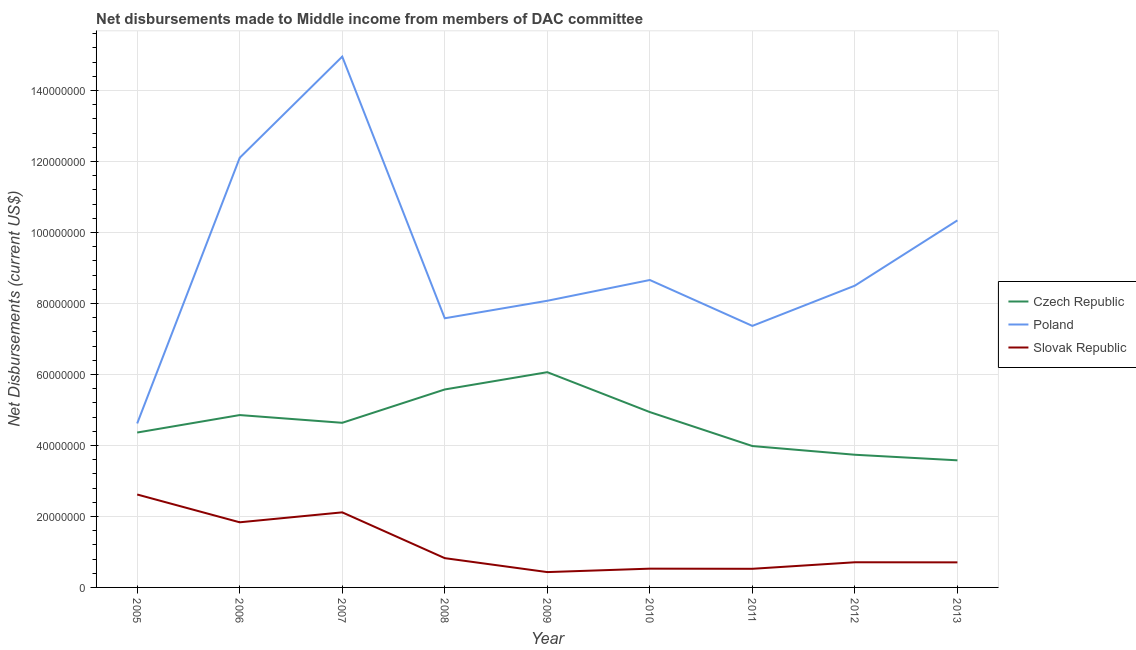Is the number of lines equal to the number of legend labels?
Give a very brief answer. Yes. What is the net disbursements made by czech republic in 2011?
Provide a succinct answer. 3.98e+07. Across all years, what is the maximum net disbursements made by slovak republic?
Your response must be concise. 2.62e+07. Across all years, what is the minimum net disbursements made by slovak republic?
Provide a short and direct response. 4.32e+06. In which year was the net disbursements made by czech republic minimum?
Offer a terse response. 2013. What is the total net disbursements made by slovak republic in the graph?
Offer a terse response. 1.03e+08. What is the difference between the net disbursements made by poland in 2010 and that in 2011?
Offer a very short reply. 1.29e+07. What is the difference between the net disbursements made by poland in 2007 and the net disbursements made by slovak republic in 2011?
Make the answer very short. 1.44e+08. What is the average net disbursements made by poland per year?
Offer a very short reply. 9.13e+07. In the year 2007, what is the difference between the net disbursements made by slovak republic and net disbursements made by czech republic?
Offer a terse response. -2.52e+07. What is the ratio of the net disbursements made by czech republic in 2007 to that in 2010?
Make the answer very short. 0.94. What is the difference between the highest and the second highest net disbursements made by poland?
Offer a terse response. 2.85e+07. What is the difference between the highest and the lowest net disbursements made by poland?
Your answer should be compact. 1.03e+08. Is the net disbursements made by slovak republic strictly greater than the net disbursements made by czech republic over the years?
Give a very brief answer. No. How many lines are there?
Your answer should be very brief. 3. What is the difference between two consecutive major ticks on the Y-axis?
Your answer should be very brief. 2.00e+07. Where does the legend appear in the graph?
Ensure brevity in your answer.  Center right. How many legend labels are there?
Make the answer very short. 3. How are the legend labels stacked?
Give a very brief answer. Vertical. What is the title of the graph?
Offer a very short reply. Net disbursements made to Middle income from members of DAC committee. What is the label or title of the X-axis?
Offer a terse response. Year. What is the label or title of the Y-axis?
Offer a very short reply. Net Disbursements (current US$). What is the Net Disbursements (current US$) in Czech Republic in 2005?
Provide a succinct answer. 4.36e+07. What is the Net Disbursements (current US$) in Poland in 2005?
Offer a very short reply. 4.62e+07. What is the Net Disbursements (current US$) of Slovak Republic in 2005?
Ensure brevity in your answer.  2.62e+07. What is the Net Disbursements (current US$) in Czech Republic in 2006?
Make the answer very short. 4.86e+07. What is the Net Disbursements (current US$) in Poland in 2006?
Ensure brevity in your answer.  1.21e+08. What is the Net Disbursements (current US$) in Slovak Republic in 2006?
Your answer should be compact. 1.84e+07. What is the Net Disbursements (current US$) of Czech Republic in 2007?
Make the answer very short. 4.64e+07. What is the Net Disbursements (current US$) in Poland in 2007?
Keep it short and to the point. 1.50e+08. What is the Net Disbursements (current US$) of Slovak Republic in 2007?
Keep it short and to the point. 2.12e+07. What is the Net Disbursements (current US$) in Czech Republic in 2008?
Your response must be concise. 5.58e+07. What is the Net Disbursements (current US$) of Poland in 2008?
Provide a succinct answer. 7.58e+07. What is the Net Disbursements (current US$) in Slovak Republic in 2008?
Offer a very short reply. 8.25e+06. What is the Net Disbursements (current US$) of Czech Republic in 2009?
Your answer should be compact. 6.06e+07. What is the Net Disbursements (current US$) of Poland in 2009?
Ensure brevity in your answer.  8.08e+07. What is the Net Disbursements (current US$) in Slovak Republic in 2009?
Your answer should be very brief. 4.32e+06. What is the Net Disbursements (current US$) of Czech Republic in 2010?
Your answer should be very brief. 4.94e+07. What is the Net Disbursements (current US$) in Poland in 2010?
Your answer should be compact. 8.66e+07. What is the Net Disbursements (current US$) of Slovak Republic in 2010?
Keep it short and to the point. 5.29e+06. What is the Net Disbursements (current US$) of Czech Republic in 2011?
Make the answer very short. 3.98e+07. What is the Net Disbursements (current US$) in Poland in 2011?
Your answer should be compact. 7.37e+07. What is the Net Disbursements (current US$) of Slovak Republic in 2011?
Make the answer very short. 5.25e+06. What is the Net Disbursements (current US$) in Czech Republic in 2012?
Your answer should be compact. 3.74e+07. What is the Net Disbursements (current US$) in Poland in 2012?
Offer a very short reply. 8.50e+07. What is the Net Disbursements (current US$) of Slovak Republic in 2012?
Provide a succinct answer. 7.09e+06. What is the Net Disbursements (current US$) in Czech Republic in 2013?
Provide a succinct answer. 3.58e+07. What is the Net Disbursements (current US$) of Poland in 2013?
Give a very brief answer. 1.03e+08. What is the Net Disbursements (current US$) in Slovak Republic in 2013?
Your answer should be compact. 7.06e+06. Across all years, what is the maximum Net Disbursements (current US$) of Czech Republic?
Your answer should be compact. 6.06e+07. Across all years, what is the maximum Net Disbursements (current US$) in Poland?
Keep it short and to the point. 1.50e+08. Across all years, what is the maximum Net Disbursements (current US$) of Slovak Republic?
Your answer should be compact. 2.62e+07. Across all years, what is the minimum Net Disbursements (current US$) of Czech Republic?
Provide a short and direct response. 3.58e+07. Across all years, what is the minimum Net Disbursements (current US$) in Poland?
Give a very brief answer. 4.62e+07. Across all years, what is the minimum Net Disbursements (current US$) in Slovak Republic?
Keep it short and to the point. 4.32e+06. What is the total Net Disbursements (current US$) of Czech Republic in the graph?
Make the answer very short. 4.17e+08. What is the total Net Disbursements (current US$) of Poland in the graph?
Provide a succinct answer. 8.22e+08. What is the total Net Disbursements (current US$) of Slovak Republic in the graph?
Give a very brief answer. 1.03e+08. What is the difference between the Net Disbursements (current US$) in Czech Republic in 2005 and that in 2006?
Ensure brevity in your answer.  -4.92e+06. What is the difference between the Net Disbursements (current US$) of Poland in 2005 and that in 2006?
Ensure brevity in your answer.  -7.48e+07. What is the difference between the Net Disbursements (current US$) of Slovak Republic in 2005 and that in 2006?
Give a very brief answer. 7.83e+06. What is the difference between the Net Disbursements (current US$) of Czech Republic in 2005 and that in 2007?
Provide a succinct answer. -2.74e+06. What is the difference between the Net Disbursements (current US$) of Poland in 2005 and that in 2007?
Your answer should be very brief. -1.03e+08. What is the difference between the Net Disbursements (current US$) in Slovak Republic in 2005 and that in 2007?
Give a very brief answer. 5.03e+06. What is the difference between the Net Disbursements (current US$) of Czech Republic in 2005 and that in 2008?
Ensure brevity in your answer.  -1.21e+07. What is the difference between the Net Disbursements (current US$) in Poland in 2005 and that in 2008?
Provide a succinct answer. -2.96e+07. What is the difference between the Net Disbursements (current US$) of Slovak Republic in 2005 and that in 2008?
Offer a terse response. 1.79e+07. What is the difference between the Net Disbursements (current US$) of Czech Republic in 2005 and that in 2009?
Ensure brevity in your answer.  -1.70e+07. What is the difference between the Net Disbursements (current US$) of Poland in 2005 and that in 2009?
Your answer should be compact. -3.46e+07. What is the difference between the Net Disbursements (current US$) of Slovak Republic in 2005 and that in 2009?
Keep it short and to the point. 2.19e+07. What is the difference between the Net Disbursements (current US$) in Czech Republic in 2005 and that in 2010?
Make the answer very short. -5.76e+06. What is the difference between the Net Disbursements (current US$) of Poland in 2005 and that in 2010?
Give a very brief answer. -4.04e+07. What is the difference between the Net Disbursements (current US$) in Slovak Republic in 2005 and that in 2010?
Make the answer very short. 2.09e+07. What is the difference between the Net Disbursements (current US$) of Czech Republic in 2005 and that in 2011?
Give a very brief answer. 3.81e+06. What is the difference between the Net Disbursements (current US$) of Poland in 2005 and that in 2011?
Offer a terse response. -2.75e+07. What is the difference between the Net Disbursements (current US$) of Slovak Republic in 2005 and that in 2011?
Ensure brevity in your answer.  2.09e+07. What is the difference between the Net Disbursements (current US$) in Czech Republic in 2005 and that in 2012?
Offer a very short reply. 6.26e+06. What is the difference between the Net Disbursements (current US$) of Poland in 2005 and that in 2012?
Offer a very short reply. -3.88e+07. What is the difference between the Net Disbursements (current US$) of Slovak Republic in 2005 and that in 2012?
Ensure brevity in your answer.  1.91e+07. What is the difference between the Net Disbursements (current US$) in Czech Republic in 2005 and that in 2013?
Offer a terse response. 7.83e+06. What is the difference between the Net Disbursements (current US$) of Poland in 2005 and that in 2013?
Make the answer very short. -5.72e+07. What is the difference between the Net Disbursements (current US$) of Slovak Republic in 2005 and that in 2013?
Offer a very short reply. 1.91e+07. What is the difference between the Net Disbursements (current US$) in Czech Republic in 2006 and that in 2007?
Offer a very short reply. 2.18e+06. What is the difference between the Net Disbursements (current US$) in Poland in 2006 and that in 2007?
Offer a terse response. -2.85e+07. What is the difference between the Net Disbursements (current US$) of Slovak Republic in 2006 and that in 2007?
Provide a short and direct response. -2.80e+06. What is the difference between the Net Disbursements (current US$) of Czech Republic in 2006 and that in 2008?
Provide a succinct answer. -7.21e+06. What is the difference between the Net Disbursements (current US$) of Poland in 2006 and that in 2008?
Provide a short and direct response. 4.52e+07. What is the difference between the Net Disbursements (current US$) of Slovak Republic in 2006 and that in 2008?
Give a very brief answer. 1.01e+07. What is the difference between the Net Disbursements (current US$) of Czech Republic in 2006 and that in 2009?
Provide a short and direct response. -1.21e+07. What is the difference between the Net Disbursements (current US$) of Poland in 2006 and that in 2009?
Keep it short and to the point. 4.03e+07. What is the difference between the Net Disbursements (current US$) in Slovak Republic in 2006 and that in 2009?
Offer a very short reply. 1.40e+07. What is the difference between the Net Disbursements (current US$) in Czech Republic in 2006 and that in 2010?
Offer a very short reply. -8.40e+05. What is the difference between the Net Disbursements (current US$) in Poland in 2006 and that in 2010?
Give a very brief answer. 3.44e+07. What is the difference between the Net Disbursements (current US$) of Slovak Republic in 2006 and that in 2010?
Give a very brief answer. 1.31e+07. What is the difference between the Net Disbursements (current US$) in Czech Republic in 2006 and that in 2011?
Give a very brief answer. 8.73e+06. What is the difference between the Net Disbursements (current US$) in Poland in 2006 and that in 2011?
Provide a succinct answer. 4.74e+07. What is the difference between the Net Disbursements (current US$) in Slovak Republic in 2006 and that in 2011?
Provide a succinct answer. 1.31e+07. What is the difference between the Net Disbursements (current US$) in Czech Republic in 2006 and that in 2012?
Offer a very short reply. 1.12e+07. What is the difference between the Net Disbursements (current US$) of Poland in 2006 and that in 2012?
Keep it short and to the point. 3.60e+07. What is the difference between the Net Disbursements (current US$) of Slovak Republic in 2006 and that in 2012?
Keep it short and to the point. 1.13e+07. What is the difference between the Net Disbursements (current US$) of Czech Republic in 2006 and that in 2013?
Provide a short and direct response. 1.28e+07. What is the difference between the Net Disbursements (current US$) in Poland in 2006 and that in 2013?
Keep it short and to the point. 1.76e+07. What is the difference between the Net Disbursements (current US$) of Slovak Republic in 2006 and that in 2013?
Offer a very short reply. 1.13e+07. What is the difference between the Net Disbursements (current US$) of Czech Republic in 2007 and that in 2008?
Ensure brevity in your answer.  -9.39e+06. What is the difference between the Net Disbursements (current US$) of Poland in 2007 and that in 2008?
Offer a very short reply. 7.37e+07. What is the difference between the Net Disbursements (current US$) in Slovak Republic in 2007 and that in 2008?
Your answer should be compact. 1.29e+07. What is the difference between the Net Disbursements (current US$) in Czech Republic in 2007 and that in 2009?
Ensure brevity in your answer.  -1.43e+07. What is the difference between the Net Disbursements (current US$) of Poland in 2007 and that in 2009?
Make the answer very short. 6.88e+07. What is the difference between the Net Disbursements (current US$) in Slovak Republic in 2007 and that in 2009?
Your answer should be very brief. 1.68e+07. What is the difference between the Net Disbursements (current US$) in Czech Republic in 2007 and that in 2010?
Offer a very short reply. -3.02e+06. What is the difference between the Net Disbursements (current US$) of Poland in 2007 and that in 2010?
Provide a succinct answer. 6.29e+07. What is the difference between the Net Disbursements (current US$) in Slovak Republic in 2007 and that in 2010?
Make the answer very short. 1.59e+07. What is the difference between the Net Disbursements (current US$) of Czech Republic in 2007 and that in 2011?
Ensure brevity in your answer.  6.55e+06. What is the difference between the Net Disbursements (current US$) of Poland in 2007 and that in 2011?
Keep it short and to the point. 7.59e+07. What is the difference between the Net Disbursements (current US$) in Slovak Republic in 2007 and that in 2011?
Ensure brevity in your answer.  1.59e+07. What is the difference between the Net Disbursements (current US$) of Czech Republic in 2007 and that in 2012?
Keep it short and to the point. 9.00e+06. What is the difference between the Net Disbursements (current US$) of Poland in 2007 and that in 2012?
Your answer should be compact. 6.45e+07. What is the difference between the Net Disbursements (current US$) in Slovak Republic in 2007 and that in 2012?
Offer a very short reply. 1.41e+07. What is the difference between the Net Disbursements (current US$) in Czech Republic in 2007 and that in 2013?
Make the answer very short. 1.06e+07. What is the difference between the Net Disbursements (current US$) of Poland in 2007 and that in 2013?
Your response must be concise. 4.61e+07. What is the difference between the Net Disbursements (current US$) of Slovak Republic in 2007 and that in 2013?
Your answer should be very brief. 1.41e+07. What is the difference between the Net Disbursements (current US$) in Czech Republic in 2008 and that in 2009?
Make the answer very short. -4.87e+06. What is the difference between the Net Disbursements (current US$) in Poland in 2008 and that in 2009?
Provide a succinct answer. -4.93e+06. What is the difference between the Net Disbursements (current US$) in Slovak Republic in 2008 and that in 2009?
Ensure brevity in your answer.  3.93e+06. What is the difference between the Net Disbursements (current US$) of Czech Republic in 2008 and that in 2010?
Offer a terse response. 6.37e+06. What is the difference between the Net Disbursements (current US$) in Poland in 2008 and that in 2010?
Keep it short and to the point. -1.08e+07. What is the difference between the Net Disbursements (current US$) of Slovak Republic in 2008 and that in 2010?
Give a very brief answer. 2.96e+06. What is the difference between the Net Disbursements (current US$) in Czech Republic in 2008 and that in 2011?
Offer a terse response. 1.59e+07. What is the difference between the Net Disbursements (current US$) in Poland in 2008 and that in 2011?
Provide a succinct answer. 2.15e+06. What is the difference between the Net Disbursements (current US$) of Slovak Republic in 2008 and that in 2011?
Keep it short and to the point. 3.00e+06. What is the difference between the Net Disbursements (current US$) of Czech Republic in 2008 and that in 2012?
Give a very brief answer. 1.84e+07. What is the difference between the Net Disbursements (current US$) of Poland in 2008 and that in 2012?
Provide a succinct answer. -9.19e+06. What is the difference between the Net Disbursements (current US$) of Slovak Republic in 2008 and that in 2012?
Ensure brevity in your answer.  1.16e+06. What is the difference between the Net Disbursements (current US$) of Czech Republic in 2008 and that in 2013?
Ensure brevity in your answer.  2.00e+07. What is the difference between the Net Disbursements (current US$) in Poland in 2008 and that in 2013?
Provide a succinct answer. -2.76e+07. What is the difference between the Net Disbursements (current US$) of Slovak Republic in 2008 and that in 2013?
Make the answer very short. 1.19e+06. What is the difference between the Net Disbursements (current US$) in Czech Republic in 2009 and that in 2010?
Keep it short and to the point. 1.12e+07. What is the difference between the Net Disbursements (current US$) of Poland in 2009 and that in 2010?
Make the answer very short. -5.85e+06. What is the difference between the Net Disbursements (current US$) in Slovak Republic in 2009 and that in 2010?
Make the answer very short. -9.70e+05. What is the difference between the Net Disbursements (current US$) of Czech Republic in 2009 and that in 2011?
Provide a short and direct response. 2.08e+07. What is the difference between the Net Disbursements (current US$) in Poland in 2009 and that in 2011?
Your answer should be compact. 7.08e+06. What is the difference between the Net Disbursements (current US$) in Slovak Republic in 2009 and that in 2011?
Ensure brevity in your answer.  -9.30e+05. What is the difference between the Net Disbursements (current US$) of Czech Republic in 2009 and that in 2012?
Make the answer very short. 2.33e+07. What is the difference between the Net Disbursements (current US$) in Poland in 2009 and that in 2012?
Your answer should be compact. -4.26e+06. What is the difference between the Net Disbursements (current US$) in Slovak Republic in 2009 and that in 2012?
Your answer should be very brief. -2.77e+06. What is the difference between the Net Disbursements (current US$) in Czech Republic in 2009 and that in 2013?
Provide a succinct answer. 2.48e+07. What is the difference between the Net Disbursements (current US$) in Poland in 2009 and that in 2013?
Offer a terse response. -2.26e+07. What is the difference between the Net Disbursements (current US$) in Slovak Republic in 2009 and that in 2013?
Your answer should be compact. -2.74e+06. What is the difference between the Net Disbursements (current US$) of Czech Republic in 2010 and that in 2011?
Make the answer very short. 9.57e+06. What is the difference between the Net Disbursements (current US$) in Poland in 2010 and that in 2011?
Your answer should be compact. 1.29e+07. What is the difference between the Net Disbursements (current US$) in Slovak Republic in 2010 and that in 2011?
Keep it short and to the point. 4.00e+04. What is the difference between the Net Disbursements (current US$) of Czech Republic in 2010 and that in 2012?
Provide a short and direct response. 1.20e+07. What is the difference between the Net Disbursements (current US$) in Poland in 2010 and that in 2012?
Offer a terse response. 1.59e+06. What is the difference between the Net Disbursements (current US$) of Slovak Republic in 2010 and that in 2012?
Give a very brief answer. -1.80e+06. What is the difference between the Net Disbursements (current US$) in Czech Republic in 2010 and that in 2013?
Keep it short and to the point. 1.36e+07. What is the difference between the Net Disbursements (current US$) in Poland in 2010 and that in 2013?
Ensure brevity in your answer.  -1.68e+07. What is the difference between the Net Disbursements (current US$) in Slovak Republic in 2010 and that in 2013?
Make the answer very short. -1.77e+06. What is the difference between the Net Disbursements (current US$) of Czech Republic in 2011 and that in 2012?
Your response must be concise. 2.45e+06. What is the difference between the Net Disbursements (current US$) in Poland in 2011 and that in 2012?
Offer a very short reply. -1.13e+07. What is the difference between the Net Disbursements (current US$) of Slovak Republic in 2011 and that in 2012?
Ensure brevity in your answer.  -1.84e+06. What is the difference between the Net Disbursements (current US$) of Czech Republic in 2011 and that in 2013?
Keep it short and to the point. 4.02e+06. What is the difference between the Net Disbursements (current US$) in Poland in 2011 and that in 2013?
Keep it short and to the point. -2.97e+07. What is the difference between the Net Disbursements (current US$) of Slovak Republic in 2011 and that in 2013?
Ensure brevity in your answer.  -1.81e+06. What is the difference between the Net Disbursements (current US$) in Czech Republic in 2012 and that in 2013?
Ensure brevity in your answer.  1.57e+06. What is the difference between the Net Disbursements (current US$) in Poland in 2012 and that in 2013?
Your response must be concise. -1.84e+07. What is the difference between the Net Disbursements (current US$) of Slovak Republic in 2012 and that in 2013?
Offer a very short reply. 3.00e+04. What is the difference between the Net Disbursements (current US$) of Czech Republic in 2005 and the Net Disbursements (current US$) of Poland in 2006?
Your answer should be very brief. -7.74e+07. What is the difference between the Net Disbursements (current US$) in Czech Republic in 2005 and the Net Disbursements (current US$) in Slovak Republic in 2006?
Your response must be concise. 2.53e+07. What is the difference between the Net Disbursements (current US$) in Poland in 2005 and the Net Disbursements (current US$) in Slovak Republic in 2006?
Ensure brevity in your answer.  2.78e+07. What is the difference between the Net Disbursements (current US$) of Czech Republic in 2005 and the Net Disbursements (current US$) of Poland in 2007?
Provide a succinct answer. -1.06e+08. What is the difference between the Net Disbursements (current US$) in Czech Republic in 2005 and the Net Disbursements (current US$) in Slovak Republic in 2007?
Make the answer very short. 2.25e+07. What is the difference between the Net Disbursements (current US$) of Poland in 2005 and the Net Disbursements (current US$) of Slovak Republic in 2007?
Give a very brief answer. 2.50e+07. What is the difference between the Net Disbursements (current US$) of Czech Republic in 2005 and the Net Disbursements (current US$) of Poland in 2008?
Provide a short and direct response. -3.22e+07. What is the difference between the Net Disbursements (current US$) in Czech Republic in 2005 and the Net Disbursements (current US$) in Slovak Republic in 2008?
Your response must be concise. 3.54e+07. What is the difference between the Net Disbursements (current US$) of Poland in 2005 and the Net Disbursements (current US$) of Slovak Republic in 2008?
Your answer should be compact. 3.79e+07. What is the difference between the Net Disbursements (current US$) in Czech Republic in 2005 and the Net Disbursements (current US$) in Poland in 2009?
Your answer should be very brief. -3.71e+07. What is the difference between the Net Disbursements (current US$) in Czech Republic in 2005 and the Net Disbursements (current US$) in Slovak Republic in 2009?
Make the answer very short. 3.93e+07. What is the difference between the Net Disbursements (current US$) in Poland in 2005 and the Net Disbursements (current US$) in Slovak Republic in 2009?
Provide a succinct answer. 4.19e+07. What is the difference between the Net Disbursements (current US$) of Czech Republic in 2005 and the Net Disbursements (current US$) of Poland in 2010?
Make the answer very short. -4.30e+07. What is the difference between the Net Disbursements (current US$) of Czech Republic in 2005 and the Net Disbursements (current US$) of Slovak Republic in 2010?
Keep it short and to the point. 3.84e+07. What is the difference between the Net Disbursements (current US$) of Poland in 2005 and the Net Disbursements (current US$) of Slovak Republic in 2010?
Offer a very short reply. 4.09e+07. What is the difference between the Net Disbursements (current US$) of Czech Republic in 2005 and the Net Disbursements (current US$) of Poland in 2011?
Offer a terse response. -3.00e+07. What is the difference between the Net Disbursements (current US$) in Czech Republic in 2005 and the Net Disbursements (current US$) in Slovak Republic in 2011?
Provide a short and direct response. 3.84e+07. What is the difference between the Net Disbursements (current US$) of Poland in 2005 and the Net Disbursements (current US$) of Slovak Republic in 2011?
Make the answer very short. 4.09e+07. What is the difference between the Net Disbursements (current US$) in Czech Republic in 2005 and the Net Disbursements (current US$) in Poland in 2012?
Offer a terse response. -4.14e+07. What is the difference between the Net Disbursements (current US$) in Czech Republic in 2005 and the Net Disbursements (current US$) in Slovak Republic in 2012?
Keep it short and to the point. 3.66e+07. What is the difference between the Net Disbursements (current US$) of Poland in 2005 and the Net Disbursements (current US$) of Slovak Republic in 2012?
Offer a terse response. 3.91e+07. What is the difference between the Net Disbursements (current US$) of Czech Republic in 2005 and the Net Disbursements (current US$) of Poland in 2013?
Make the answer very short. -5.98e+07. What is the difference between the Net Disbursements (current US$) in Czech Republic in 2005 and the Net Disbursements (current US$) in Slovak Republic in 2013?
Your answer should be compact. 3.66e+07. What is the difference between the Net Disbursements (current US$) of Poland in 2005 and the Net Disbursements (current US$) of Slovak Republic in 2013?
Offer a terse response. 3.91e+07. What is the difference between the Net Disbursements (current US$) in Czech Republic in 2006 and the Net Disbursements (current US$) in Poland in 2007?
Provide a succinct answer. -1.01e+08. What is the difference between the Net Disbursements (current US$) in Czech Republic in 2006 and the Net Disbursements (current US$) in Slovak Republic in 2007?
Offer a terse response. 2.74e+07. What is the difference between the Net Disbursements (current US$) in Poland in 2006 and the Net Disbursements (current US$) in Slovak Republic in 2007?
Your response must be concise. 9.99e+07. What is the difference between the Net Disbursements (current US$) in Czech Republic in 2006 and the Net Disbursements (current US$) in Poland in 2008?
Offer a terse response. -2.73e+07. What is the difference between the Net Disbursements (current US$) of Czech Republic in 2006 and the Net Disbursements (current US$) of Slovak Republic in 2008?
Give a very brief answer. 4.03e+07. What is the difference between the Net Disbursements (current US$) of Poland in 2006 and the Net Disbursements (current US$) of Slovak Republic in 2008?
Provide a short and direct response. 1.13e+08. What is the difference between the Net Disbursements (current US$) of Czech Republic in 2006 and the Net Disbursements (current US$) of Poland in 2009?
Offer a very short reply. -3.22e+07. What is the difference between the Net Disbursements (current US$) of Czech Republic in 2006 and the Net Disbursements (current US$) of Slovak Republic in 2009?
Keep it short and to the point. 4.42e+07. What is the difference between the Net Disbursements (current US$) of Poland in 2006 and the Net Disbursements (current US$) of Slovak Republic in 2009?
Provide a short and direct response. 1.17e+08. What is the difference between the Net Disbursements (current US$) of Czech Republic in 2006 and the Net Disbursements (current US$) of Poland in 2010?
Offer a very short reply. -3.80e+07. What is the difference between the Net Disbursements (current US$) in Czech Republic in 2006 and the Net Disbursements (current US$) in Slovak Republic in 2010?
Your response must be concise. 4.33e+07. What is the difference between the Net Disbursements (current US$) of Poland in 2006 and the Net Disbursements (current US$) of Slovak Republic in 2010?
Provide a short and direct response. 1.16e+08. What is the difference between the Net Disbursements (current US$) in Czech Republic in 2006 and the Net Disbursements (current US$) in Poland in 2011?
Give a very brief answer. -2.51e+07. What is the difference between the Net Disbursements (current US$) of Czech Republic in 2006 and the Net Disbursements (current US$) of Slovak Republic in 2011?
Ensure brevity in your answer.  4.33e+07. What is the difference between the Net Disbursements (current US$) in Poland in 2006 and the Net Disbursements (current US$) in Slovak Republic in 2011?
Provide a short and direct response. 1.16e+08. What is the difference between the Net Disbursements (current US$) in Czech Republic in 2006 and the Net Disbursements (current US$) in Poland in 2012?
Provide a short and direct response. -3.65e+07. What is the difference between the Net Disbursements (current US$) of Czech Republic in 2006 and the Net Disbursements (current US$) of Slovak Republic in 2012?
Ensure brevity in your answer.  4.15e+07. What is the difference between the Net Disbursements (current US$) in Poland in 2006 and the Net Disbursements (current US$) in Slovak Republic in 2012?
Your response must be concise. 1.14e+08. What is the difference between the Net Disbursements (current US$) in Czech Republic in 2006 and the Net Disbursements (current US$) in Poland in 2013?
Offer a terse response. -5.48e+07. What is the difference between the Net Disbursements (current US$) of Czech Republic in 2006 and the Net Disbursements (current US$) of Slovak Republic in 2013?
Your answer should be compact. 4.15e+07. What is the difference between the Net Disbursements (current US$) of Poland in 2006 and the Net Disbursements (current US$) of Slovak Republic in 2013?
Your answer should be compact. 1.14e+08. What is the difference between the Net Disbursements (current US$) of Czech Republic in 2007 and the Net Disbursements (current US$) of Poland in 2008?
Give a very brief answer. -2.94e+07. What is the difference between the Net Disbursements (current US$) in Czech Republic in 2007 and the Net Disbursements (current US$) in Slovak Republic in 2008?
Ensure brevity in your answer.  3.81e+07. What is the difference between the Net Disbursements (current US$) in Poland in 2007 and the Net Disbursements (current US$) in Slovak Republic in 2008?
Your answer should be very brief. 1.41e+08. What is the difference between the Net Disbursements (current US$) of Czech Republic in 2007 and the Net Disbursements (current US$) of Poland in 2009?
Your answer should be very brief. -3.44e+07. What is the difference between the Net Disbursements (current US$) in Czech Republic in 2007 and the Net Disbursements (current US$) in Slovak Republic in 2009?
Give a very brief answer. 4.21e+07. What is the difference between the Net Disbursements (current US$) of Poland in 2007 and the Net Disbursements (current US$) of Slovak Republic in 2009?
Offer a terse response. 1.45e+08. What is the difference between the Net Disbursements (current US$) of Czech Republic in 2007 and the Net Disbursements (current US$) of Poland in 2010?
Your answer should be compact. -4.02e+07. What is the difference between the Net Disbursements (current US$) of Czech Republic in 2007 and the Net Disbursements (current US$) of Slovak Republic in 2010?
Your response must be concise. 4.11e+07. What is the difference between the Net Disbursements (current US$) in Poland in 2007 and the Net Disbursements (current US$) in Slovak Republic in 2010?
Your answer should be compact. 1.44e+08. What is the difference between the Net Disbursements (current US$) in Czech Republic in 2007 and the Net Disbursements (current US$) in Poland in 2011?
Ensure brevity in your answer.  -2.73e+07. What is the difference between the Net Disbursements (current US$) of Czech Republic in 2007 and the Net Disbursements (current US$) of Slovak Republic in 2011?
Your response must be concise. 4.11e+07. What is the difference between the Net Disbursements (current US$) of Poland in 2007 and the Net Disbursements (current US$) of Slovak Republic in 2011?
Provide a succinct answer. 1.44e+08. What is the difference between the Net Disbursements (current US$) of Czech Republic in 2007 and the Net Disbursements (current US$) of Poland in 2012?
Your answer should be compact. -3.86e+07. What is the difference between the Net Disbursements (current US$) of Czech Republic in 2007 and the Net Disbursements (current US$) of Slovak Republic in 2012?
Provide a short and direct response. 3.93e+07. What is the difference between the Net Disbursements (current US$) of Poland in 2007 and the Net Disbursements (current US$) of Slovak Republic in 2012?
Provide a succinct answer. 1.42e+08. What is the difference between the Net Disbursements (current US$) of Czech Republic in 2007 and the Net Disbursements (current US$) of Poland in 2013?
Ensure brevity in your answer.  -5.70e+07. What is the difference between the Net Disbursements (current US$) in Czech Republic in 2007 and the Net Disbursements (current US$) in Slovak Republic in 2013?
Your answer should be compact. 3.93e+07. What is the difference between the Net Disbursements (current US$) of Poland in 2007 and the Net Disbursements (current US$) of Slovak Republic in 2013?
Give a very brief answer. 1.42e+08. What is the difference between the Net Disbursements (current US$) of Czech Republic in 2008 and the Net Disbursements (current US$) of Poland in 2009?
Provide a succinct answer. -2.50e+07. What is the difference between the Net Disbursements (current US$) in Czech Republic in 2008 and the Net Disbursements (current US$) in Slovak Republic in 2009?
Give a very brief answer. 5.14e+07. What is the difference between the Net Disbursements (current US$) of Poland in 2008 and the Net Disbursements (current US$) of Slovak Republic in 2009?
Offer a very short reply. 7.15e+07. What is the difference between the Net Disbursements (current US$) of Czech Republic in 2008 and the Net Disbursements (current US$) of Poland in 2010?
Keep it short and to the point. -3.08e+07. What is the difference between the Net Disbursements (current US$) in Czech Republic in 2008 and the Net Disbursements (current US$) in Slovak Republic in 2010?
Your answer should be very brief. 5.05e+07. What is the difference between the Net Disbursements (current US$) of Poland in 2008 and the Net Disbursements (current US$) of Slovak Republic in 2010?
Provide a succinct answer. 7.05e+07. What is the difference between the Net Disbursements (current US$) in Czech Republic in 2008 and the Net Disbursements (current US$) in Poland in 2011?
Offer a terse response. -1.79e+07. What is the difference between the Net Disbursements (current US$) of Czech Republic in 2008 and the Net Disbursements (current US$) of Slovak Republic in 2011?
Your answer should be compact. 5.05e+07. What is the difference between the Net Disbursements (current US$) in Poland in 2008 and the Net Disbursements (current US$) in Slovak Republic in 2011?
Ensure brevity in your answer.  7.06e+07. What is the difference between the Net Disbursements (current US$) in Czech Republic in 2008 and the Net Disbursements (current US$) in Poland in 2012?
Offer a terse response. -2.92e+07. What is the difference between the Net Disbursements (current US$) in Czech Republic in 2008 and the Net Disbursements (current US$) in Slovak Republic in 2012?
Offer a terse response. 4.87e+07. What is the difference between the Net Disbursements (current US$) in Poland in 2008 and the Net Disbursements (current US$) in Slovak Republic in 2012?
Keep it short and to the point. 6.87e+07. What is the difference between the Net Disbursements (current US$) in Czech Republic in 2008 and the Net Disbursements (current US$) in Poland in 2013?
Your answer should be compact. -4.76e+07. What is the difference between the Net Disbursements (current US$) in Czech Republic in 2008 and the Net Disbursements (current US$) in Slovak Republic in 2013?
Your answer should be very brief. 4.87e+07. What is the difference between the Net Disbursements (current US$) in Poland in 2008 and the Net Disbursements (current US$) in Slovak Republic in 2013?
Your response must be concise. 6.88e+07. What is the difference between the Net Disbursements (current US$) of Czech Republic in 2009 and the Net Disbursements (current US$) of Poland in 2010?
Provide a succinct answer. -2.60e+07. What is the difference between the Net Disbursements (current US$) in Czech Republic in 2009 and the Net Disbursements (current US$) in Slovak Republic in 2010?
Your answer should be very brief. 5.54e+07. What is the difference between the Net Disbursements (current US$) in Poland in 2009 and the Net Disbursements (current US$) in Slovak Republic in 2010?
Offer a terse response. 7.55e+07. What is the difference between the Net Disbursements (current US$) of Czech Republic in 2009 and the Net Disbursements (current US$) of Poland in 2011?
Offer a terse response. -1.30e+07. What is the difference between the Net Disbursements (current US$) in Czech Republic in 2009 and the Net Disbursements (current US$) in Slovak Republic in 2011?
Provide a succinct answer. 5.54e+07. What is the difference between the Net Disbursements (current US$) of Poland in 2009 and the Net Disbursements (current US$) of Slovak Republic in 2011?
Offer a very short reply. 7.55e+07. What is the difference between the Net Disbursements (current US$) in Czech Republic in 2009 and the Net Disbursements (current US$) in Poland in 2012?
Provide a succinct answer. -2.44e+07. What is the difference between the Net Disbursements (current US$) of Czech Republic in 2009 and the Net Disbursements (current US$) of Slovak Republic in 2012?
Your response must be concise. 5.36e+07. What is the difference between the Net Disbursements (current US$) in Poland in 2009 and the Net Disbursements (current US$) in Slovak Republic in 2012?
Offer a terse response. 7.37e+07. What is the difference between the Net Disbursements (current US$) of Czech Republic in 2009 and the Net Disbursements (current US$) of Poland in 2013?
Offer a terse response. -4.28e+07. What is the difference between the Net Disbursements (current US$) of Czech Republic in 2009 and the Net Disbursements (current US$) of Slovak Republic in 2013?
Make the answer very short. 5.36e+07. What is the difference between the Net Disbursements (current US$) in Poland in 2009 and the Net Disbursements (current US$) in Slovak Republic in 2013?
Offer a terse response. 7.37e+07. What is the difference between the Net Disbursements (current US$) of Czech Republic in 2010 and the Net Disbursements (current US$) of Poland in 2011?
Keep it short and to the point. -2.43e+07. What is the difference between the Net Disbursements (current US$) in Czech Republic in 2010 and the Net Disbursements (current US$) in Slovak Republic in 2011?
Your response must be concise. 4.42e+07. What is the difference between the Net Disbursements (current US$) in Poland in 2010 and the Net Disbursements (current US$) in Slovak Republic in 2011?
Ensure brevity in your answer.  8.14e+07. What is the difference between the Net Disbursements (current US$) of Czech Republic in 2010 and the Net Disbursements (current US$) of Poland in 2012?
Provide a short and direct response. -3.56e+07. What is the difference between the Net Disbursements (current US$) of Czech Republic in 2010 and the Net Disbursements (current US$) of Slovak Republic in 2012?
Your response must be concise. 4.23e+07. What is the difference between the Net Disbursements (current US$) in Poland in 2010 and the Net Disbursements (current US$) in Slovak Republic in 2012?
Give a very brief answer. 7.95e+07. What is the difference between the Net Disbursements (current US$) in Czech Republic in 2010 and the Net Disbursements (current US$) in Poland in 2013?
Offer a very short reply. -5.40e+07. What is the difference between the Net Disbursements (current US$) in Czech Republic in 2010 and the Net Disbursements (current US$) in Slovak Republic in 2013?
Offer a terse response. 4.23e+07. What is the difference between the Net Disbursements (current US$) of Poland in 2010 and the Net Disbursements (current US$) of Slovak Republic in 2013?
Make the answer very short. 7.96e+07. What is the difference between the Net Disbursements (current US$) of Czech Republic in 2011 and the Net Disbursements (current US$) of Poland in 2012?
Make the answer very short. -4.52e+07. What is the difference between the Net Disbursements (current US$) in Czech Republic in 2011 and the Net Disbursements (current US$) in Slovak Republic in 2012?
Your response must be concise. 3.27e+07. What is the difference between the Net Disbursements (current US$) in Poland in 2011 and the Net Disbursements (current US$) in Slovak Republic in 2012?
Keep it short and to the point. 6.66e+07. What is the difference between the Net Disbursements (current US$) of Czech Republic in 2011 and the Net Disbursements (current US$) of Poland in 2013?
Offer a terse response. -6.36e+07. What is the difference between the Net Disbursements (current US$) of Czech Republic in 2011 and the Net Disbursements (current US$) of Slovak Republic in 2013?
Offer a very short reply. 3.28e+07. What is the difference between the Net Disbursements (current US$) of Poland in 2011 and the Net Disbursements (current US$) of Slovak Republic in 2013?
Offer a terse response. 6.66e+07. What is the difference between the Net Disbursements (current US$) of Czech Republic in 2012 and the Net Disbursements (current US$) of Poland in 2013?
Provide a succinct answer. -6.60e+07. What is the difference between the Net Disbursements (current US$) of Czech Republic in 2012 and the Net Disbursements (current US$) of Slovak Republic in 2013?
Offer a very short reply. 3.03e+07. What is the difference between the Net Disbursements (current US$) of Poland in 2012 and the Net Disbursements (current US$) of Slovak Republic in 2013?
Provide a succinct answer. 7.80e+07. What is the average Net Disbursements (current US$) in Czech Republic per year?
Give a very brief answer. 4.64e+07. What is the average Net Disbursements (current US$) of Poland per year?
Keep it short and to the point. 9.13e+07. What is the average Net Disbursements (current US$) in Slovak Republic per year?
Provide a short and direct response. 1.14e+07. In the year 2005, what is the difference between the Net Disbursements (current US$) of Czech Republic and Net Disbursements (current US$) of Poland?
Your answer should be very brief. -2.55e+06. In the year 2005, what is the difference between the Net Disbursements (current US$) of Czech Republic and Net Disbursements (current US$) of Slovak Republic?
Make the answer very short. 1.75e+07. In the year 2005, what is the difference between the Net Disbursements (current US$) of Poland and Net Disbursements (current US$) of Slovak Republic?
Ensure brevity in your answer.  2.00e+07. In the year 2006, what is the difference between the Net Disbursements (current US$) in Czech Republic and Net Disbursements (current US$) in Poland?
Your response must be concise. -7.25e+07. In the year 2006, what is the difference between the Net Disbursements (current US$) of Czech Republic and Net Disbursements (current US$) of Slovak Republic?
Your answer should be very brief. 3.02e+07. In the year 2006, what is the difference between the Net Disbursements (current US$) of Poland and Net Disbursements (current US$) of Slovak Republic?
Give a very brief answer. 1.03e+08. In the year 2007, what is the difference between the Net Disbursements (current US$) of Czech Republic and Net Disbursements (current US$) of Poland?
Your answer should be very brief. -1.03e+08. In the year 2007, what is the difference between the Net Disbursements (current US$) in Czech Republic and Net Disbursements (current US$) in Slovak Republic?
Provide a short and direct response. 2.52e+07. In the year 2007, what is the difference between the Net Disbursements (current US$) in Poland and Net Disbursements (current US$) in Slovak Republic?
Your answer should be compact. 1.28e+08. In the year 2008, what is the difference between the Net Disbursements (current US$) of Czech Republic and Net Disbursements (current US$) of Poland?
Ensure brevity in your answer.  -2.01e+07. In the year 2008, what is the difference between the Net Disbursements (current US$) of Czech Republic and Net Disbursements (current US$) of Slovak Republic?
Offer a very short reply. 4.75e+07. In the year 2008, what is the difference between the Net Disbursements (current US$) in Poland and Net Disbursements (current US$) in Slovak Republic?
Keep it short and to the point. 6.76e+07. In the year 2009, what is the difference between the Net Disbursements (current US$) in Czech Republic and Net Disbursements (current US$) in Poland?
Keep it short and to the point. -2.01e+07. In the year 2009, what is the difference between the Net Disbursements (current US$) in Czech Republic and Net Disbursements (current US$) in Slovak Republic?
Ensure brevity in your answer.  5.63e+07. In the year 2009, what is the difference between the Net Disbursements (current US$) of Poland and Net Disbursements (current US$) of Slovak Republic?
Offer a very short reply. 7.64e+07. In the year 2010, what is the difference between the Net Disbursements (current US$) in Czech Republic and Net Disbursements (current US$) in Poland?
Make the answer very short. -3.72e+07. In the year 2010, what is the difference between the Net Disbursements (current US$) in Czech Republic and Net Disbursements (current US$) in Slovak Republic?
Give a very brief answer. 4.41e+07. In the year 2010, what is the difference between the Net Disbursements (current US$) in Poland and Net Disbursements (current US$) in Slovak Republic?
Your answer should be very brief. 8.13e+07. In the year 2011, what is the difference between the Net Disbursements (current US$) in Czech Republic and Net Disbursements (current US$) in Poland?
Your response must be concise. -3.38e+07. In the year 2011, what is the difference between the Net Disbursements (current US$) in Czech Republic and Net Disbursements (current US$) in Slovak Republic?
Your answer should be very brief. 3.46e+07. In the year 2011, what is the difference between the Net Disbursements (current US$) of Poland and Net Disbursements (current US$) of Slovak Republic?
Give a very brief answer. 6.84e+07. In the year 2012, what is the difference between the Net Disbursements (current US$) in Czech Republic and Net Disbursements (current US$) in Poland?
Provide a short and direct response. -4.76e+07. In the year 2012, what is the difference between the Net Disbursements (current US$) of Czech Republic and Net Disbursements (current US$) of Slovak Republic?
Your response must be concise. 3.03e+07. In the year 2012, what is the difference between the Net Disbursements (current US$) of Poland and Net Disbursements (current US$) of Slovak Republic?
Make the answer very short. 7.79e+07. In the year 2013, what is the difference between the Net Disbursements (current US$) in Czech Republic and Net Disbursements (current US$) in Poland?
Your answer should be very brief. -6.76e+07. In the year 2013, what is the difference between the Net Disbursements (current US$) in Czech Republic and Net Disbursements (current US$) in Slovak Republic?
Your answer should be compact. 2.88e+07. In the year 2013, what is the difference between the Net Disbursements (current US$) in Poland and Net Disbursements (current US$) in Slovak Republic?
Make the answer very short. 9.64e+07. What is the ratio of the Net Disbursements (current US$) in Czech Republic in 2005 to that in 2006?
Offer a terse response. 0.9. What is the ratio of the Net Disbursements (current US$) in Poland in 2005 to that in 2006?
Give a very brief answer. 0.38. What is the ratio of the Net Disbursements (current US$) of Slovak Republic in 2005 to that in 2006?
Provide a short and direct response. 1.43. What is the ratio of the Net Disbursements (current US$) in Czech Republic in 2005 to that in 2007?
Your response must be concise. 0.94. What is the ratio of the Net Disbursements (current US$) in Poland in 2005 to that in 2007?
Your answer should be compact. 0.31. What is the ratio of the Net Disbursements (current US$) in Slovak Republic in 2005 to that in 2007?
Offer a very short reply. 1.24. What is the ratio of the Net Disbursements (current US$) in Czech Republic in 2005 to that in 2008?
Ensure brevity in your answer.  0.78. What is the ratio of the Net Disbursements (current US$) of Poland in 2005 to that in 2008?
Make the answer very short. 0.61. What is the ratio of the Net Disbursements (current US$) in Slovak Republic in 2005 to that in 2008?
Offer a very short reply. 3.17. What is the ratio of the Net Disbursements (current US$) in Czech Republic in 2005 to that in 2009?
Your response must be concise. 0.72. What is the ratio of the Net Disbursements (current US$) in Poland in 2005 to that in 2009?
Offer a terse response. 0.57. What is the ratio of the Net Disbursements (current US$) of Slovak Republic in 2005 to that in 2009?
Make the answer very short. 6.06. What is the ratio of the Net Disbursements (current US$) of Czech Republic in 2005 to that in 2010?
Make the answer very short. 0.88. What is the ratio of the Net Disbursements (current US$) of Poland in 2005 to that in 2010?
Offer a very short reply. 0.53. What is the ratio of the Net Disbursements (current US$) of Slovak Republic in 2005 to that in 2010?
Your answer should be compact. 4.95. What is the ratio of the Net Disbursements (current US$) of Czech Republic in 2005 to that in 2011?
Provide a short and direct response. 1.1. What is the ratio of the Net Disbursements (current US$) of Poland in 2005 to that in 2011?
Your answer should be very brief. 0.63. What is the ratio of the Net Disbursements (current US$) in Slovak Republic in 2005 to that in 2011?
Keep it short and to the point. 4.99. What is the ratio of the Net Disbursements (current US$) in Czech Republic in 2005 to that in 2012?
Provide a short and direct response. 1.17. What is the ratio of the Net Disbursements (current US$) of Poland in 2005 to that in 2012?
Offer a terse response. 0.54. What is the ratio of the Net Disbursements (current US$) of Slovak Republic in 2005 to that in 2012?
Offer a terse response. 3.69. What is the ratio of the Net Disbursements (current US$) in Czech Republic in 2005 to that in 2013?
Your answer should be compact. 1.22. What is the ratio of the Net Disbursements (current US$) of Poland in 2005 to that in 2013?
Your response must be concise. 0.45. What is the ratio of the Net Disbursements (current US$) of Slovak Republic in 2005 to that in 2013?
Keep it short and to the point. 3.71. What is the ratio of the Net Disbursements (current US$) in Czech Republic in 2006 to that in 2007?
Your answer should be compact. 1.05. What is the ratio of the Net Disbursements (current US$) of Poland in 2006 to that in 2007?
Your response must be concise. 0.81. What is the ratio of the Net Disbursements (current US$) of Slovak Republic in 2006 to that in 2007?
Your answer should be very brief. 0.87. What is the ratio of the Net Disbursements (current US$) of Czech Republic in 2006 to that in 2008?
Provide a succinct answer. 0.87. What is the ratio of the Net Disbursements (current US$) of Poland in 2006 to that in 2008?
Offer a very short reply. 1.6. What is the ratio of the Net Disbursements (current US$) in Slovak Republic in 2006 to that in 2008?
Give a very brief answer. 2.22. What is the ratio of the Net Disbursements (current US$) of Czech Republic in 2006 to that in 2009?
Keep it short and to the point. 0.8. What is the ratio of the Net Disbursements (current US$) of Poland in 2006 to that in 2009?
Provide a short and direct response. 1.5. What is the ratio of the Net Disbursements (current US$) in Slovak Republic in 2006 to that in 2009?
Your answer should be very brief. 4.25. What is the ratio of the Net Disbursements (current US$) of Czech Republic in 2006 to that in 2010?
Keep it short and to the point. 0.98. What is the ratio of the Net Disbursements (current US$) of Poland in 2006 to that in 2010?
Ensure brevity in your answer.  1.4. What is the ratio of the Net Disbursements (current US$) in Slovak Republic in 2006 to that in 2010?
Keep it short and to the point. 3.47. What is the ratio of the Net Disbursements (current US$) in Czech Republic in 2006 to that in 2011?
Make the answer very short. 1.22. What is the ratio of the Net Disbursements (current US$) of Poland in 2006 to that in 2011?
Your answer should be compact. 1.64. What is the ratio of the Net Disbursements (current US$) in Slovak Republic in 2006 to that in 2011?
Give a very brief answer. 3.5. What is the ratio of the Net Disbursements (current US$) in Czech Republic in 2006 to that in 2012?
Your answer should be compact. 1.3. What is the ratio of the Net Disbursements (current US$) of Poland in 2006 to that in 2012?
Provide a succinct answer. 1.42. What is the ratio of the Net Disbursements (current US$) in Slovak Republic in 2006 to that in 2012?
Give a very brief answer. 2.59. What is the ratio of the Net Disbursements (current US$) in Czech Republic in 2006 to that in 2013?
Ensure brevity in your answer.  1.36. What is the ratio of the Net Disbursements (current US$) of Poland in 2006 to that in 2013?
Ensure brevity in your answer.  1.17. What is the ratio of the Net Disbursements (current US$) of Slovak Republic in 2006 to that in 2013?
Your response must be concise. 2.6. What is the ratio of the Net Disbursements (current US$) in Czech Republic in 2007 to that in 2008?
Keep it short and to the point. 0.83. What is the ratio of the Net Disbursements (current US$) in Poland in 2007 to that in 2008?
Make the answer very short. 1.97. What is the ratio of the Net Disbursements (current US$) in Slovak Republic in 2007 to that in 2008?
Your answer should be very brief. 2.56. What is the ratio of the Net Disbursements (current US$) in Czech Republic in 2007 to that in 2009?
Offer a very short reply. 0.76. What is the ratio of the Net Disbursements (current US$) in Poland in 2007 to that in 2009?
Keep it short and to the point. 1.85. What is the ratio of the Net Disbursements (current US$) in Slovak Republic in 2007 to that in 2009?
Your response must be concise. 4.9. What is the ratio of the Net Disbursements (current US$) of Czech Republic in 2007 to that in 2010?
Provide a succinct answer. 0.94. What is the ratio of the Net Disbursements (current US$) in Poland in 2007 to that in 2010?
Make the answer very short. 1.73. What is the ratio of the Net Disbursements (current US$) of Slovak Republic in 2007 to that in 2010?
Give a very brief answer. 4. What is the ratio of the Net Disbursements (current US$) in Czech Republic in 2007 to that in 2011?
Make the answer very short. 1.16. What is the ratio of the Net Disbursements (current US$) in Poland in 2007 to that in 2011?
Offer a terse response. 2.03. What is the ratio of the Net Disbursements (current US$) of Slovak Republic in 2007 to that in 2011?
Provide a short and direct response. 4.03. What is the ratio of the Net Disbursements (current US$) in Czech Republic in 2007 to that in 2012?
Make the answer very short. 1.24. What is the ratio of the Net Disbursements (current US$) in Poland in 2007 to that in 2012?
Give a very brief answer. 1.76. What is the ratio of the Net Disbursements (current US$) of Slovak Republic in 2007 to that in 2012?
Your answer should be very brief. 2.98. What is the ratio of the Net Disbursements (current US$) in Czech Republic in 2007 to that in 2013?
Ensure brevity in your answer.  1.3. What is the ratio of the Net Disbursements (current US$) in Poland in 2007 to that in 2013?
Give a very brief answer. 1.45. What is the ratio of the Net Disbursements (current US$) in Slovak Republic in 2007 to that in 2013?
Offer a terse response. 3. What is the ratio of the Net Disbursements (current US$) in Czech Republic in 2008 to that in 2009?
Offer a terse response. 0.92. What is the ratio of the Net Disbursements (current US$) of Poland in 2008 to that in 2009?
Your answer should be very brief. 0.94. What is the ratio of the Net Disbursements (current US$) in Slovak Republic in 2008 to that in 2009?
Your response must be concise. 1.91. What is the ratio of the Net Disbursements (current US$) in Czech Republic in 2008 to that in 2010?
Provide a short and direct response. 1.13. What is the ratio of the Net Disbursements (current US$) in Poland in 2008 to that in 2010?
Your response must be concise. 0.88. What is the ratio of the Net Disbursements (current US$) of Slovak Republic in 2008 to that in 2010?
Offer a very short reply. 1.56. What is the ratio of the Net Disbursements (current US$) in Czech Republic in 2008 to that in 2011?
Your answer should be very brief. 1.4. What is the ratio of the Net Disbursements (current US$) in Poland in 2008 to that in 2011?
Your response must be concise. 1.03. What is the ratio of the Net Disbursements (current US$) in Slovak Republic in 2008 to that in 2011?
Offer a terse response. 1.57. What is the ratio of the Net Disbursements (current US$) in Czech Republic in 2008 to that in 2012?
Your answer should be compact. 1.49. What is the ratio of the Net Disbursements (current US$) of Poland in 2008 to that in 2012?
Provide a short and direct response. 0.89. What is the ratio of the Net Disbursements (current US$) in Slovak Republic in 2008 to that in 2012?
Your response must be concise. 1.16. What is the ratio of the Net Disbursements (current US$) in Czech Republic in 2008 to that in 2013?
Your response must be concise. 1.56. What is the ratio of the Net Disbursements (current US$) in Poland in 2008 to that in 2013?
Keep it short and to the point. 0.73. What is the ratio of the Net Disbursements (current US$) in Slovak Republic in 2008 to that in 2013?
Offer a very short reply. 1.17. What is the ratio of the Net Disbursements (current US$) of Czech Republic in 2009 to that in 2010?
Give a very brief answer. 1.23. What is the ratio of the Net Disbursements (current US$) in Poland in 2009 to that in 2010?
Keep it short and to the point. 0.93. What is the ratio of the Net Disbursements (current US$) of Slovak Republic in 2009 to that in 2010?
Ensure brevity in your answer.  0.82. What is the ratio of the Net Disbursements (current US$) in Czech Republic in 2009 to that in 2011?
Offer a terse response. 1.52. What is the ratio of the Net Disbursements (current US$) in Poland in 2009 to that in 2011?
Your answer should be very brief. 1.1. What is the ratio of the Net Disbursements (current US$) of Slovak Republic in 2009 to that in 2011?
Your answer should be compact. 0.82. What is the ratio of the Net Disbursements (current US$) of Czech Republic in 2009 to that in 2012?
Give a very brief answer. 1.62. What is the ratio of the Net Disbursements (current US$) in Poland in 2009 to that in 2012?
Make the answer very short. 0.95. What is the ratio of the Net Disbursements (current US$) of Slovak Republic in 2009 to that in 2012?
Ensure brevity in your answer.  0.61. What is the ratio of the Net Disbursements (current US$) in Czech Republic in 2009 to that in 2013?
Your answer should be very brief. 1.69. What is the ratio of the Net Disbursements (current US$) of Poland in 2009 to that in 2013?
Your response must be concise. 0.78. What is the ratio of the Net Disbursements (current US$) in Slovak Republic in 2009 to that in 2013?
Your answer should be compact. 0.61. What is the ratio of the Net Disbursements (current US$) in Czech Republic in 2010 to that in 2011?
Offer a terse response. 1.24. What is the ratio of the Net Disbursements (current US$) in Poland in 2010 to that in 2011?
Your response must be concise. 1.18. What is the ratio of the Net Disbursements (current US$) in Slovak Republic in 2010 to that in 2011?
Provide a short and direct response. 1.01. What is the ratio of the Net Disbursements (current US$) of Czech Republic in 2010 to that in 2012?
Your response must be concise. 1.32. What is the ratio of the Net Disbursements (current US$) in Poland in 2010 to that in 2012?
Offer a terse response. 1.02. What is the ratio of the Net Disbursements (current US$) in Slovak Republic in 2010 to that in 2012?
Offer a terse response. 0.75. What is the ratio of the Net Disbursements (current US$) of Czech Republic in 2010 to that in 2013?
Your answer should be very brief. 1.38. What is the ratio of the Net Disbursements (current US$) of Poland in 2010 to that in 2013?
Your answer should be compact. 0.84. What is the ratio of the Net Disbursements (current US$) of Slovak Republic in 2010 to that in 2013?
Provide a succinct answer. 0.75. What is the ratio of the Net Disbursements (current US$) in Czech Republic in 2011 to that in 2012?
Provide a short and direct response. 1.07. What is the ratio of the Net Disbursements (current US$) of Poland in 2011 to that in 2012?
Keep it short and to the point. 0.87. What is the ratio of the Net Disbursements (current US$) of Slovak Republic in 2011 to that in 2012?
Your answer should be very brief. 0.74. What is the ratio of the Net Disbursements (current US$) of Czech Republic in 2011 to that in 2013?
Make the answer very short. 1.11. What is the ratio of the Net Disbursements (current US$) in Poland in 2011 to that in 2013?
Give a very brief answer. 0.71. What is the ratio of the Net Disbursements (current US$) in Slovak Republic in 2011 to that in 2013?
Ensure brevity in your answer.  0.74. What is the ratio of the Net Disbursements (current US$) in Czech Republic in 2012 to that in 2013?
Make the answer very short. 1.04. What is the ratio of the Net Disbursements (current US$) of Poland in 2012 to that in 2013?
Give a very brief answer. 0.82. What is the difference between the highest and the second highest Net Disbursements (current US$) in Czech Republic?
Your answer should be very brief. 4.87e+06. What is the difference between the highest and the second highest Net Disbursements (current US$) of Poland?
Your response must be concise. 2.85e+07. What is the difference between the highest and the second highest Net Disbursements (current US$) in Slovak Republic?
Provide a short and direct response. 5.03e+06. What is the difference between the highest and the lowest Net Disbursements (current US$) in Czech Republic?
Provide a succinct answer. 2.48e+07. What is the difference between the highest and the lowest Net Disbursements (current US$) of Poland?
Ensure brevity in your answer.  1.03e+08. What is the difference between the highest and the lowest Net Disbursements (current US$) in Slovak Republic?
Your answer should be very brief. 2.19e+07. 